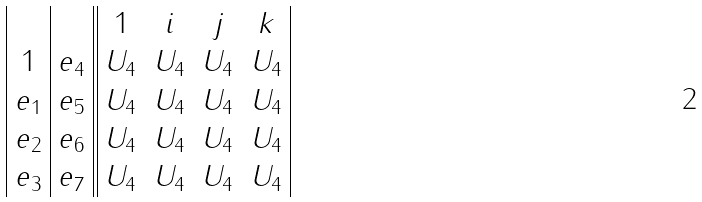Convert formula to latex. <formula><loc_0><loc_0><loc_500><loc_500>\begin{array} { | c | c | | c c c c | } & & 1 & i & j & k \\ 1 & e _ { 4 } & U _ { 4 } & U _ { 4 } & U _ { 4 } & U _ { 4 } \\ e _ { 1 } & e _ { 5 } & U _ { 4 } & U _ { 4 } & U _ { 4 } & U _ { 4 } \\ e _ { 2 } & e _ { 6 } & U _ { 4 } & U _ { 4 } & U _ { 4 } & U _ { 4 } \\ e _ { 3 } & e _ { 7 } & U _ { 4 } & U _ { 4 } & U _ { 4 } & U _ { 4 } \\ \end{array}</formula> 